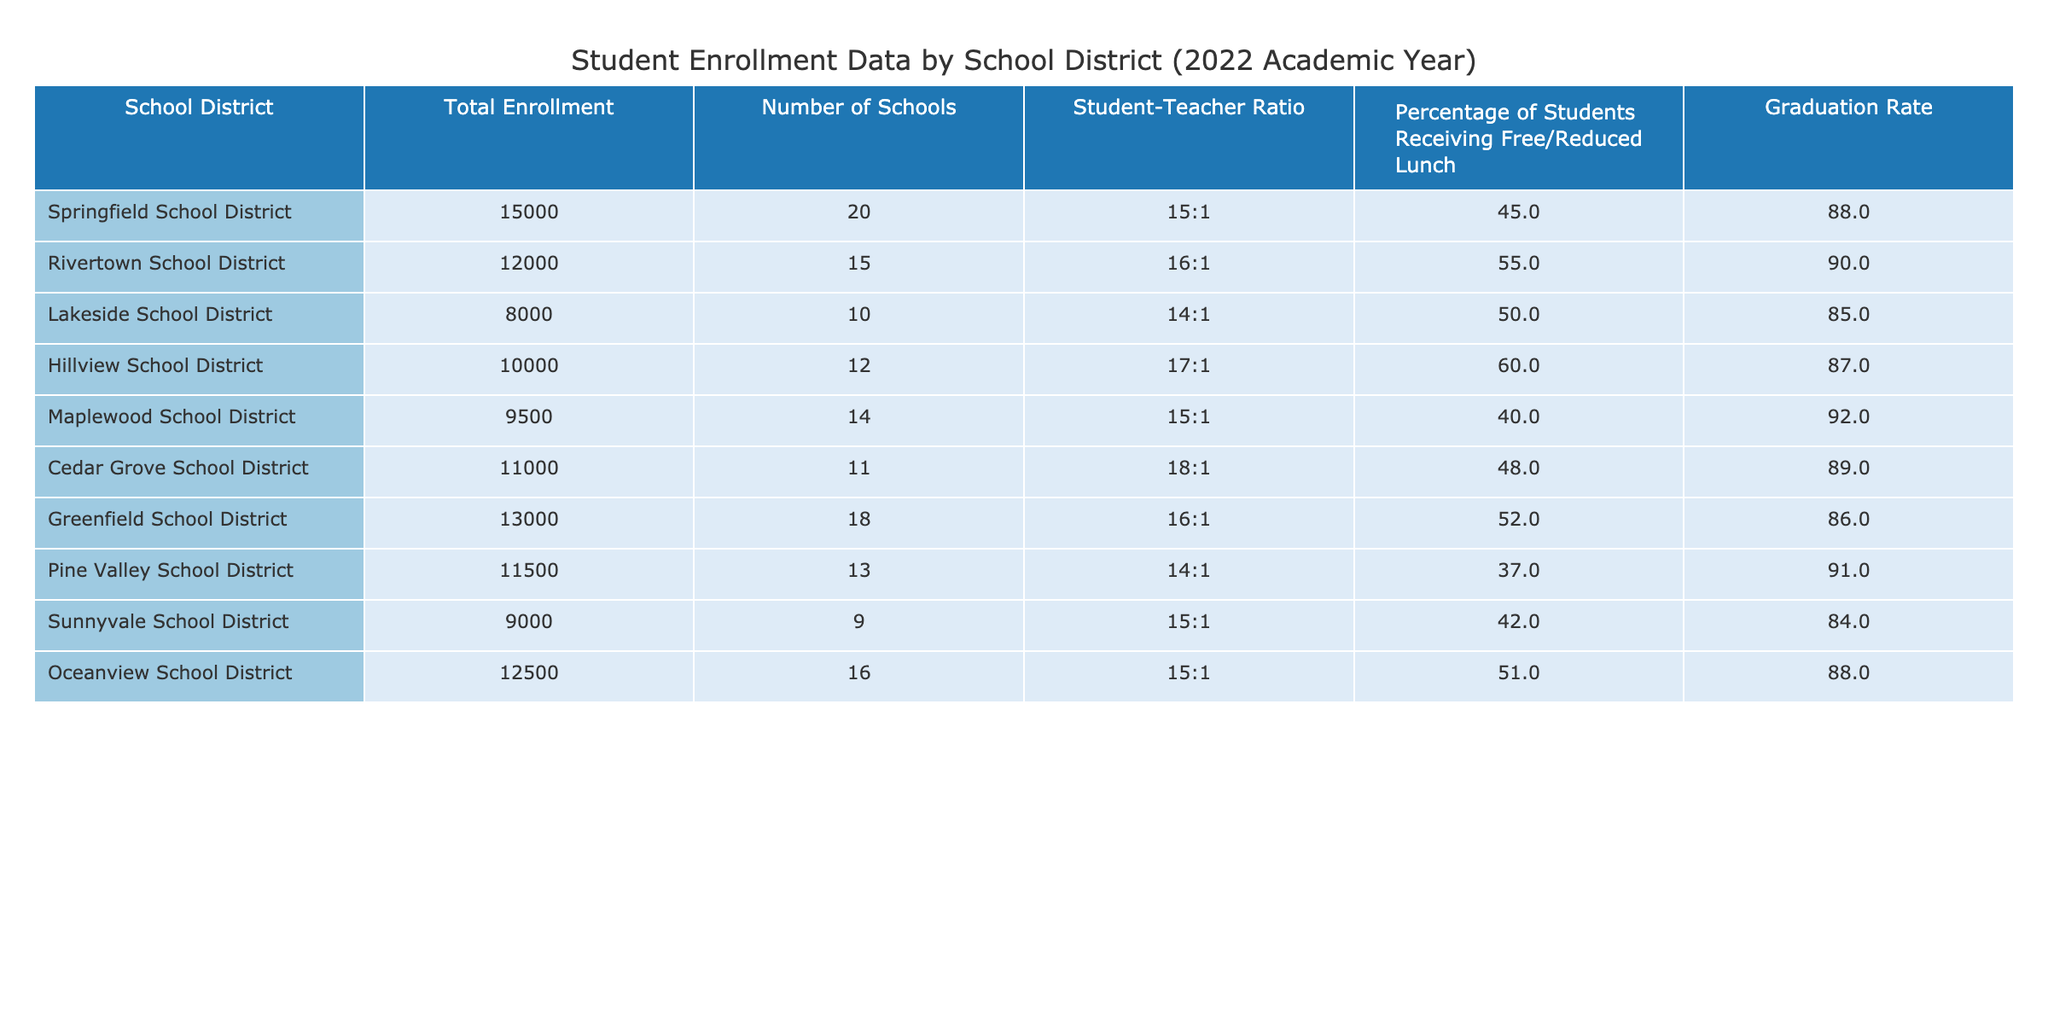What is the total enrollment in the Springfield School District? The table shows the total enrollment for the Springfield School District listed directly under the "Total Enrollment" column. The value is 15000.
Answer: 15000 Which school district has the highest graduation rate? The graduation rates for each district are compared. The table indicates that Maplewood School District has the highest graduation rate at 92%.
Answer: Maplewood School District Is the student-teacher ratio in Hillview School District lower than the ratio in Pine Valley School District? The student-teacher ratio for Hillview School District is 17:1, while Pine Valley School District's ratio is 14:1. Since 17 > 14, Hillview's ratio is not lower.
Answer: No What is the average percentage of students receiving free/reduced lunch across all school districts? First, the percentages are extracted: 45%, 55%, 50%, 60%, 40%, 48%, 52%, 37%, 42%, and 51%. Their sum is 435%, and dividing by 10 (the number of districts) gives an average of 43.5%.
Answer: 43.5% Which school district has the lowest total enrollment? By examining the "Total Enrollment" column, the transformation shows that Sunnyvale School District has the lowest total enrollment of 9000.
Answer: Sunnyvale School District Do more than half of the school districts have a student-teacher ratio of less than or equal to 15:1? The ratios are 15:1 for Springfield, Lakeside, Maplewood, and Pine Valley and greater for others. With 4 districts at or below 15:1 out of 10, this is less than half.
Answer: No What is the difference in graduation rates between Rivertown and Lakeside School Districts? Rivertown has a graduation rate of 90%, and Lakeside has a rate of 85%. The difference is calculated as 90 - 85 = 5.
Answer: 5 Which districts have a higher percentage of students receiving free/reduced lunch, and what is the average percentage among them? The districts exceeding 50% are Rivertown (55%), Hillview (60%), Cedar Grove (48%), and Greenfield (52%). These values are summed: 55 + 60 + 52 + 60 = 235%. With 4 districts, the average is 235/4 = 59.75%.
Answer: 59.75% 